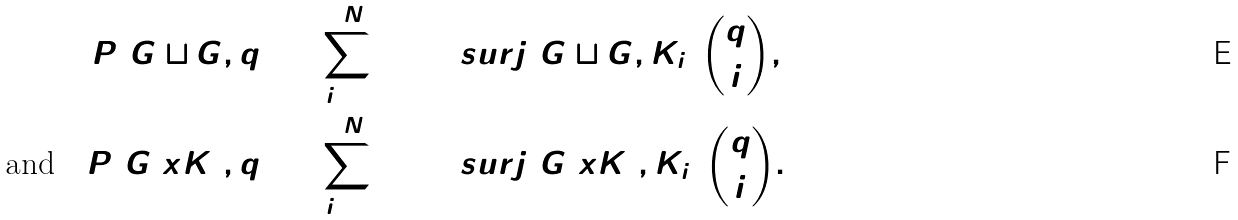Convert formula to latex. <formula><loc_0><loc_0><loc_500><loc_500>P ( G \sqcup G , q ) & = \sum _ { i = 0 } ^ { 2 N } \hom ^ { \ } s u r j ( G \sqcup G , K _ { i } ) \binom { q } { i } , \\ \text {and} \quad P ( G \ x K _ { 2 } , q ) & = \sum _ { i = 0 } ^ { 2 N } \hom ^ { \ } s u r j ( G \ x K _ { 2 } , K _ { i } ) \binom { q } { i } .</formula> 